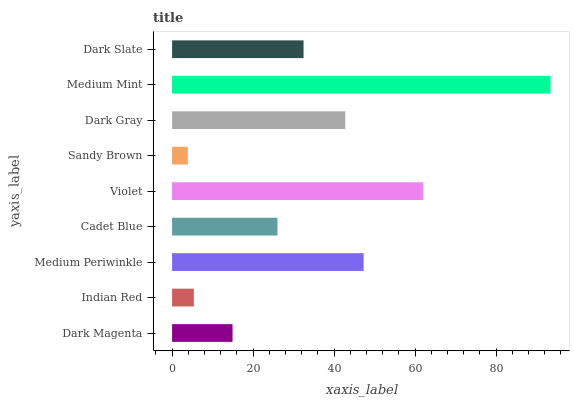Is Sandy Brown the minimum?
Answer yes or no. Yes. Is Medium Mint the maximum?
Answer yes or no. Yes. Is Indian Red the minimum?
Answer yes or no. No. Is Indian Red the maximum?
Answer yes or no. No. Is Dark Magenta greater than Indian Red?
Answer yes or no. Yes. Is Indian Red less than Dark Magenta?
Answer yes or no. Yes. Is Indian Red greater than Dark Magenta?
Answer yes or no. No. Is Dark Magenta less than Indian Red?
Answer yes or no. No. Is Dark Slate the high median?
Answer yes or no. Yes. Is Dark Slate the low median?
Answer yes or no. Yes. Is Medium Periwinkle the high median?
Answer yes or no. No. Is Medium Mint the low median?
Answer yes or no. No. 